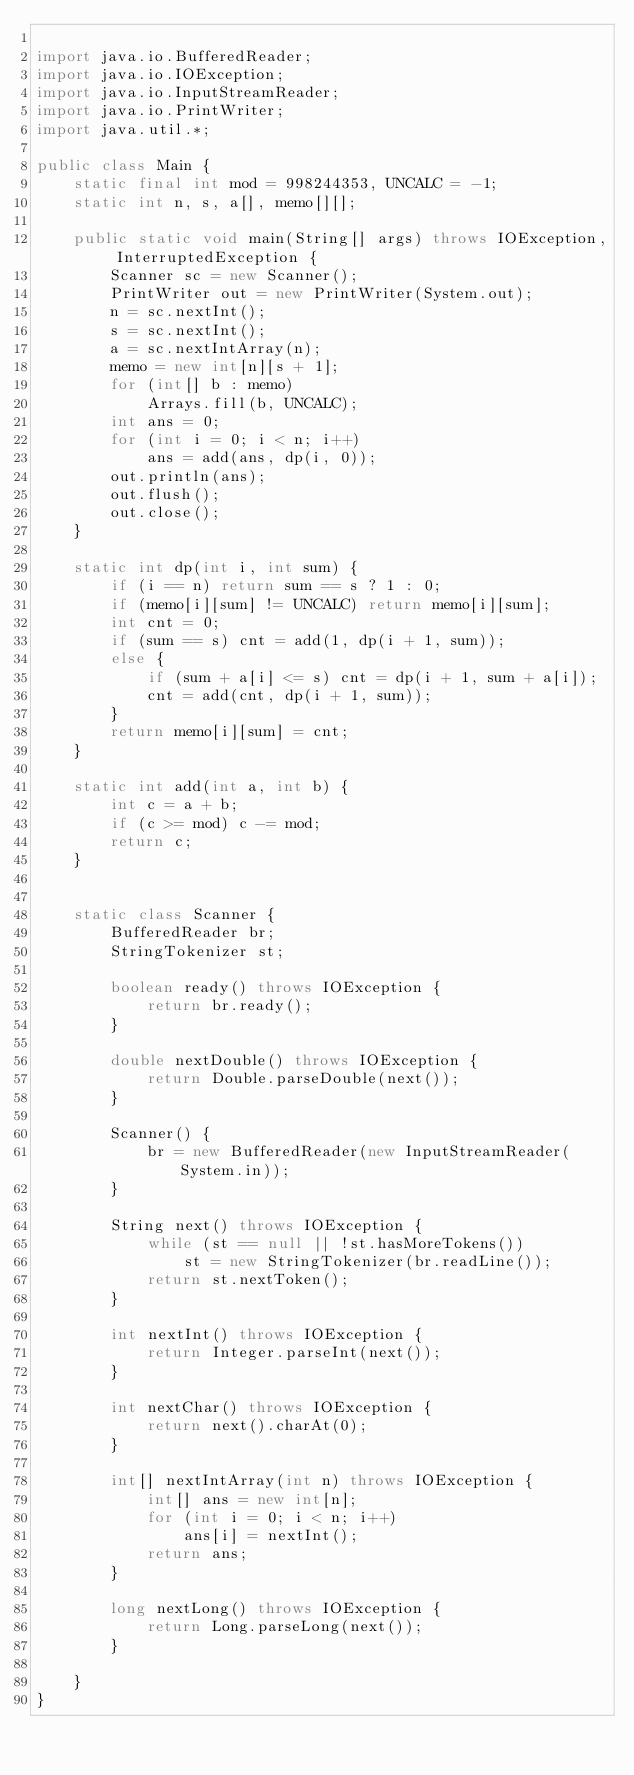<code> <loc_0><loc_0><loc_500><loc_500><_Java_>
import java.io.BufferedReader;
import java.io.IOException;
import java.io.InputStreamReader;
import java.io.PrintWriter;
import java.util.*;

public class Main {
    static final int mod = 998244353, UNCALC = -1;
    static int n, s, a[], memo[][];

    public static void main(String[] args) throws IOException, InterruptedException {
        Scanner sc = new Scanner();
        PrintWriter out = new PrintWriter(System.out);
        n = sc.nextInt();
        s = sc.nextInt();
        a = sc.nextIntArray(n);
        memo = new int[n][s + 1];
        for (int[] b : memo)
            Arrays.fill(b, UNCALC);
        int ans = 0;
        for (int i = 0; i < n; i++)
            ans = add(ans, dp(i, 0));
        out.println(ans);
        out.flush();
        out.close();
    }

    static int dp(int i, int sum) {
        if (i == n) return sum == s ? 1 : 0;
        if (memo[i][sum] != UNCALC) return memo[i][sum];
        int cnt = 0;
        if (sum == s) cnt = add(1, dp(i + 1, sum));
        else {
            if (sum + a[i] <= s) cnt = dp(i + 1, sum + a[i]);
            cnt = add(cnt, dp(i + 1, sum));
        }
        return memo[i][sum] = cnt;
    }

    static int add(int a, int b) {
        int c = a + b;
        if (c >= mod) c -= mod;
        return c;
    }


    static class Scanner {
        BufferedReader br;
        StringTokenizer st;

        boolean ready() throws IOException {
            return br.ready();
        }

        double nextDouble() throws IOException {
            return Double.parseDouble(next());
        }

        Scanner() {
            br = new BufferedReader(new InputStreamReader(System.in));
        }

        String next() throws IOException {
            while (st == null || !st.hasMoreTokens())
                st = new StringTokenizer(br.readLine());
            return st.nextToken();
        }

        int nextInt() throws IOException {
            return Integer.parseInt(next());
        }

        int nextChar() throws IOException {
            return next().charAt(0);
        }

        int[] nextIntArray(int n) throws IOException {
            int[] ans = new int[n];
            for (int i = 0; i < n; i++)
                ans[i] = nextInt();
            return ans;
        }

        long nextLong() throws IOException {
            return Long.parseLong(next());
        }

    }
}
</code> 